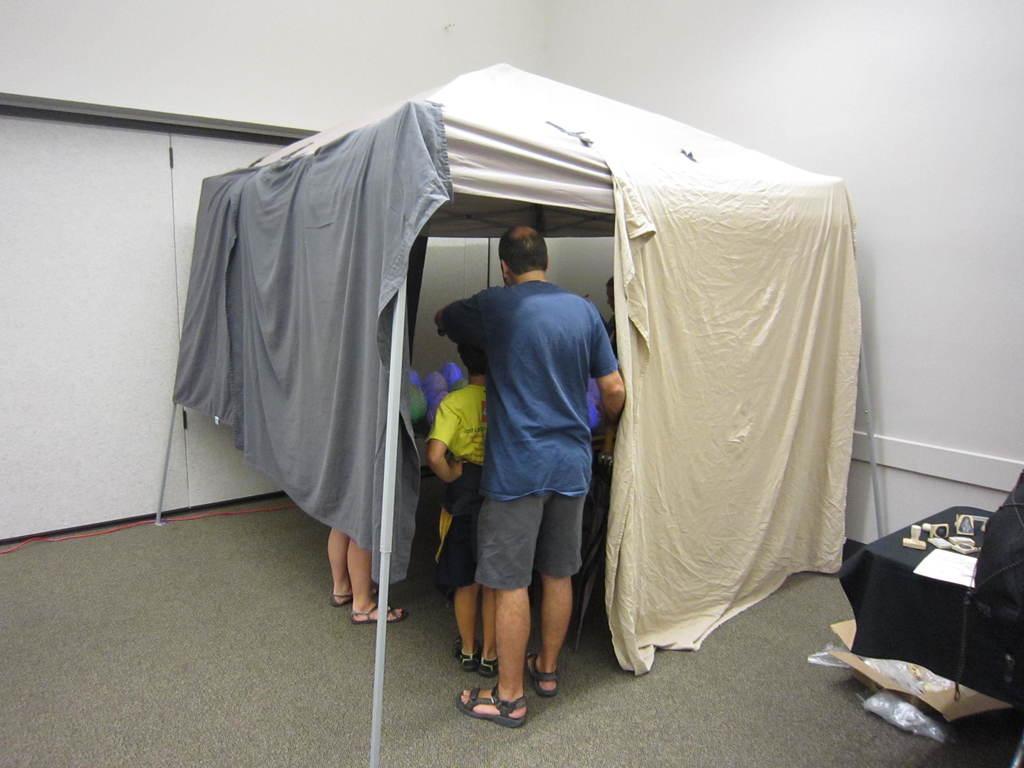What structure can be seen in the image? There is a tent in the image. Who or what is inside the tent? There are people standing inside the tent. What piece of furniture is visible in the image? There is a table visible in the image. What is on top of the table? There are objects on the table. Can you tell me how many engines are visible in the image? There are no engines present in the image. What type of lake can be seen near the tent in the image? There is no lake visible in the image; it only features a tent, people, and a table. 